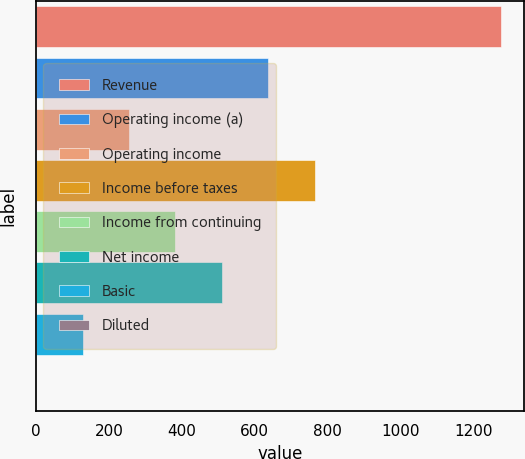Convert chart to OTSL. <chart><loc_0><loc_0><loc_500><loc_500><bar_chart><fcel>Revenue<fcel>Operating income (a)<fcel>Operating income<fcel>Income before taxes<fcel>Income from continuing<fcel>Net income<fcel>Basic<fcel>Diluted<nl><fcel>1273.4<fcel>637.09<fcel>255.28<fcel>764.36<fcel>382.55<fcel>509.82<fcel>128.01<fcel>0.74<nl></chart> 